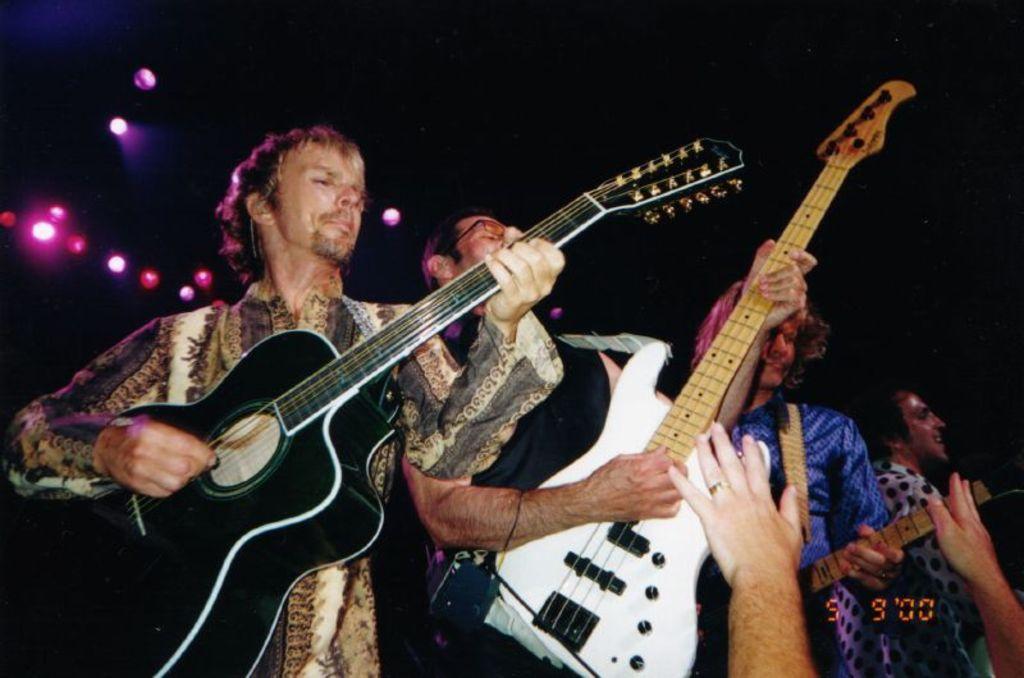Can you describe this image briefly? In this picture we can see four men holding guitars in their hands and playing it and in background we can see lights and it is dark. 